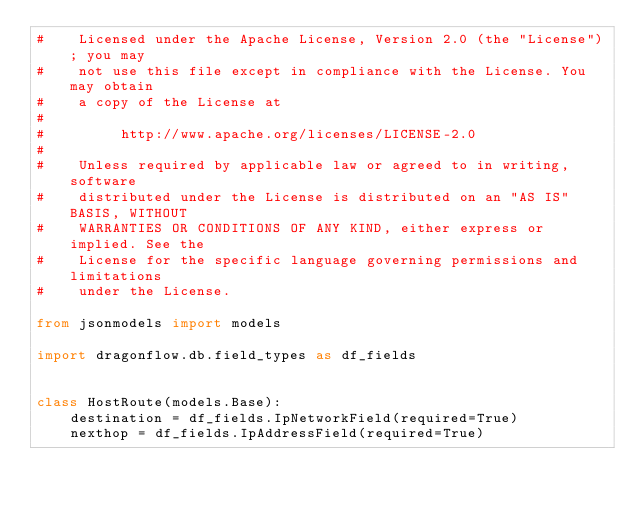Convert code to text. <code><loc_0><loc_0><loc_500><loc_500><_Python_>#    Licensed under the Apache License, Version 2.0 (the "License"); you may
#    not use this file except in compliance with the License. You may obtain
#    a copy of the License at
#
#         http://www.apache.org/licenses/LICENSE-2.0
#
#    Unless required by applicable law or agreed to in writing, software
#    distributed under the License is distributed on an "AS IS" BASIS, WITHOUT
#    WARRANTIES OR CONDITIONS OF ANY KIND, either express or implied. See the
#    License for the specific language governing permissions and limitations
#    under the License.

from jsonmodels import models

import dragonflow.db.field_types as df_fields


class HostRoute(models.Base):
    destination = df_fields.IpNetworkField(required=True)
    nexthop = df_fields.IpAddressField(required=True)
</code> 